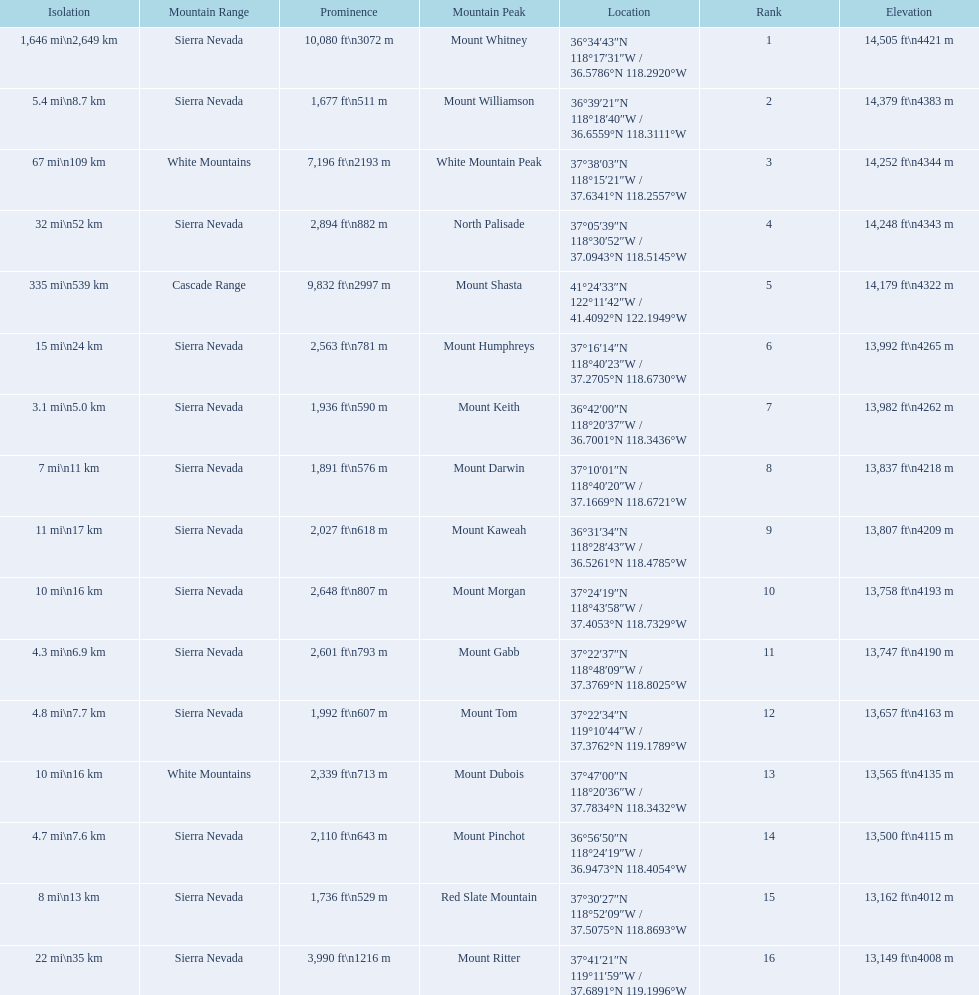What are the mountain peaks? Mount Whitney, Mount Williamson, White Mountain Peak, North Palisade, Mount Shasta, Mount Humphreys, Mount Keith, Mount Darwin, Mount Kaweah, Mount Morgan, Mount Gabb, Mount Tom, Mount Dubois, Mount Pinchot, Red Slate Mountain, Mount Ritter. Of these, which one has a prominence more than 10,000 ft? Mount Whitney. 